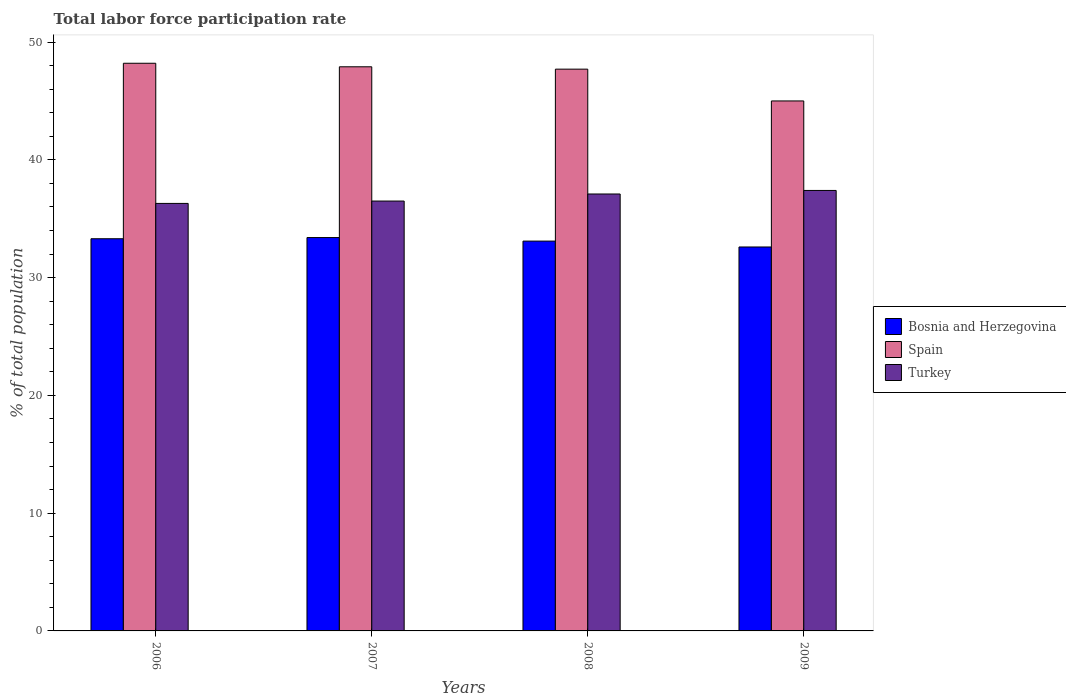How many different coloured bars are there?
Offer a very short reply. 3. How many bars are there on the 3rd tick from the left?
Make the answer very short. 3. What is the label of the 3rd group of bars from the left?
Offer a very short reply. 2008. What is the total labor force participation rate in Bosnia and Herzegovina in 2008?
Give a very brief answer. 33.1. Across all years, what is the maximum total labor force participation rate in Spain?
Offer a very short reply. 48.2. In which year was the total labor force participation rate in Spain maximum?
Your answer should be compact. 2006. What is the total total labor force participation rate in Spain in the graph?
Keep it short and to the point. 188.8. What is the difference between the total labor force participation rate in Bosnia and Herzegovina in 2006 and that in 2007?
Provide a short and direct response. -0.1. What is the difference between the total labor force participation rate in Spain in 2007 and the total labor force participation rate in Bosnia and Herzegovina in 2009?
Your answer should be compact. 15.3. What is the average total labor force participation rate in Turkey per year?
Your answer should be very brief. 36.82. In the year 2009, what is the difference between the total labor force participation rate in Spain and total labor force participation rate in Bosnia and Herzegovina?
Provide a succinct answer. 12.4. What is the ratio of the total labor force participation rate in Turkey in 2006 to that in 2008?
Your response must be concise. 0.98. Is the total labor force participation rate in Spain in 2008 less than that in 2009?
Your answer should be very brief. No. What is the difference between the highest and the second highest total labor force participation rate in Spain?
Your response must be concise. 0.3. What is the difference between the highest and the lowest total labor force participation rate in Spain?
Give a very brief answer. 3.2. What does the 3rd bar from the left in 2007 represents?
Ensure brevity in your answer.  Turkey. What does the 2nd bar from the right in 2009 represents?
Your answer should be very brief. Spain. Is it the case that in every year, the sum of the total labor force participation rate in Bosnia and Herzegovina and total labor force participation rate in Turkey is greater than the total labor force participation rate in Spain?
Keep it short and to the point. Yes. What is the difference between two consecutive major ticks on the Y-axis?
Offer a terse response. 10. Does the graph contain any zero values?
Ensure brevity in your answer.  No. Does the graph contain grids?
Keep it short and to the point. No. How are the legend labels stacked?
Keep it short and to the point. Vertical. What is the title of the graph?
Make the answer very short. Total labor force participation rate. What is the label or title of the X-axis?
Your answer should be compact. Years. What is the label or title of the Y-axis?
Your answer should be compact. % of total population. What is the % of total population of Bosnia and Herzegovina in 2006?
Ensure brevity in your answer.  33.3. What is the % of total population in Spain in 2006?
Your answer should be compact. 48.2. What is the % of total population in Turkey in 2006?
Your response must be concise. 36.3. What is the % of total population of Bosnia and Herzegovina in 2007?
Provide a short and direct response. 33.4. What is the % of total population in Spain in 2007?
Your answer should be compact. 47.9. What is the % of total population of Turkey in 2007?
Your answer should be compact. 36.5. What is the % of total population in Bosnia and Herzegovina in 2008?
Keep it short and to the point. 33.1. What is the % of total population of Spain in 2008?
Keep it short and to the point. 47.7. What is the % of total population of Turkey in 2008?
Your response must be concise. 37.1. What is the % of total population in Bosnia and Herzegovina in 2009?
Make the answer very short. 32.6. What is the % of total population in Spain in 2009?
Give a very brief answer. 45. What is the % of total population of Turkey in 2009?
Keep it short and to the point. 37.4. Across all years, what is the maximum % of total population of Bosnia and Herzegovina?
Keep it short and to the point. 33.4. Across all years, what is the maximum % of total population of Spain?
Your answer should be compact. 48.2. Across all years, what is the maximum % of total population in Turkey?
Your answer should be compact. 37.4. Across all years, what is the minimum % of total population in Bosnia and Herzegovina?
Offer a very short reply. 32.6. Across all years, what is the minimum % of total population of Turkey?
Offer a very short reply. 36.3. What is the total % of total population of Bosnia and Herzegovina in the graph?
Give a very brief answer. 132.4. What is the total % of total population of Spain in the graph?
Make the answer very short. 188.8. What is the total % of total population of Turkey in the graph?
Offer a very short reply. 147.3. What is the difference between the % of total population of Turkey in 2006 and that in 2007?
Give a very brief answer. -0.2. What is the difference between the % of total population in Bosnia and Herzegovina in 2006 and that in 2008?
Your answer should be very brief. 0.2. What is the difference between the % of total population in Turkey in 2006 and that in 2008?
Your response must be concise. -0.8. What is the difference between the % of total population in Turkey in 2006 and that in 2009?
Your answer should be compact. -1.1. What is the difference between the % of total population of Turkey in 2007 and that in 2008?
Keep it short and to the point. -0.6. What is the difference between the % of total population of Bosnia and Herzegovina in 2007 and that in 2009?
Ensure brevity in your answer.  0.8. What is the difference between the % of total population in Spain in 2007 and that in 2009?
Your answer should be very brief. 2.9. What is the difference between the % of total population in Turkey in 2007 and that in 2009?
Your answer should be compact. -0.9. What is the difference between the % of total population of Bosnia and Herzegovina in 2008 and that in 2009?
Your answer should be compact. 0.5. What is the difference between the % of total population in Turkey in 2008 and that in 2009?
Offer a terse response. -0.3. What is the difference between the % of total population of Bosnia and Herzegovina in 2006 and the % of total population of Spain in 2007?
Make the answer very short. -14.6. What is the difference between the % of total population in Bosnia and Herzegovina in 2006 and the % of total population in Spain in 2008?
Give a very brief answer. -14.4. What is the difference between the % of total population of Spain in 2006 and the % of total population of Turkey in 2008?
Provide a succinct answer. 11.1. What is the difference between the % of total population of Bosnia and Herzegovina in 2006 and the % of total population of Turkey in 2009?
Give a very brief answer. -4.1. What is the difference between the % of total population of Bosnia and Herzegovina in 2007 and the % of total population of Spain in 2008?
Ensure brevity in your answer.  -14.3. What is the difference between the % of total population of Bosnia and Herzegovina in 2007 and the % of total population of Spain in 2009?
Keep it short and to the point. -11.6. What is the difference between the % of total population of Spain in 2007 and the % of total population of Turkey in 2009?
Your response must be concise. 10.5. What is the difference between the % of total population in Bosnia and Herzegovina in 2008 and the % of total population in Spain in 2009?
Your answer should be very brief. -11.9. What is the difference between the % of total population of Bosnia and Herzegovina in 2008 and the % of total population of Turkey in 2009?
Your answer should be compact. -4.3. What is the average % of total population in Bosnia and Herzegovina per year?
Keep it short and to the point. 33.1. What is the average % of total population of Spain per year?
Your answer should be compact. 47.2. What is the average % of total population in Turkey per year?
Give a very brief answer. 36.83. In the year 2006, what is the difference between the % of total population in Bosnia and Herzegovina and % of total population in Spain?
Your answer should be very brief. -14.9. In the year 2006, what is the difference between the % of total population in Bosnia and Herzegovina and % of total population in Turkey?
Your answer should be compact. -3. In the year 2006, what is the difference between the % of total population of Spain and % of total population of Turkey?
Ensure brevity in your answer.  11.9. In the year 2008, what is the difference between the % of total population in Bosnia and Herzegovina and % of total population in Spain?
Offer a terse response. -14.6. In the year 2009, what is the difference between the % of total population in Bosnia and Herzegovina and % of total population in Turkey?
Offer a very short reply. -4.8. In the year 2009, what is the difference between the % of total population in Spain and % of total population in Turkey?
Make the answer very short. 7.6. What is the ratio of the % of total population of Turkey in 2006 to that in 2007?
Your answer should be compact. 0.99. What is the ratio of the % of total population of Bosnia and Herzegovina in 2006 to that in 2008?
Your response must be concise. 1.01. What is the ratio of the % of total population of Spain in 2006 to that in 2008?
Your response must be concise. 1.01. What is the ratio of the % of total population of Turkey in 2006 to that in 2008?
Ensure brevity in your answer.  0.98. What is the ratio of the % of total population of Bosnia and Herzegovina in 2006 to that in 2009?
Ensure brevity in your answer.  1.02. What is the ratio of the % of total population in Spain in 2006 to that in 2009?
Make the answer very short. 1.07. What is the ratio of the % of total population in Turkey in 2006 to that in 2009?
Provide a short and direct response. 0.97. What is the ratio of the % of total population in Bosnia and Herzegovina in 2007 to that in 2008?
Provide a succinct answer. 1.01. What is the ratio of the % of total population of Turkey in 2007 to that in 2008?
Give a very brief answer. 0.98. What is the ratio of the % of total population in Bosnia and Herzegovina in 2007 to that in 2009?
Offer a terse response. 1.02. What is the ratio of the % of total population of Spain in 2007 to that in 2009?
Offer a terse response. 1.06. What is the ratio of the % of total population of Turkey in 2007 to that in 2009?
Give a very brief answer. 0.98. What is the ratio of the % of total population of Bosnia and Herzegovina in 2008 to that in 2009?
Offer a terse response. 1.02. What is the ratio of the % of total population in Spain in 2008 to that in 2009?
Provide a short and direct response. 1.06. What is the ratio of the % of total population in Turkey in 2008 to that in 2009?
Offer a very short reply. 0.99. What is the difference between the highest and the second highest % of total population of Bosnia and Herzegovina?
Offer a very short reply. 0.1. What is the difference between the highest and the second highest % of total population in Spain?
Your response must be concise. 0.3. What is the difference between the highest and the lowest % of total population in Bosnia and Herzegovina?
Ensure brevity in your answer.  0.8. What is the difference between the highest and the lowest % of total population in Spain?
Offer a terse response. 3.2. What is the difference between the highest and the lowest % of total population of Turkey?
Your answer should be compact. 1.1. 